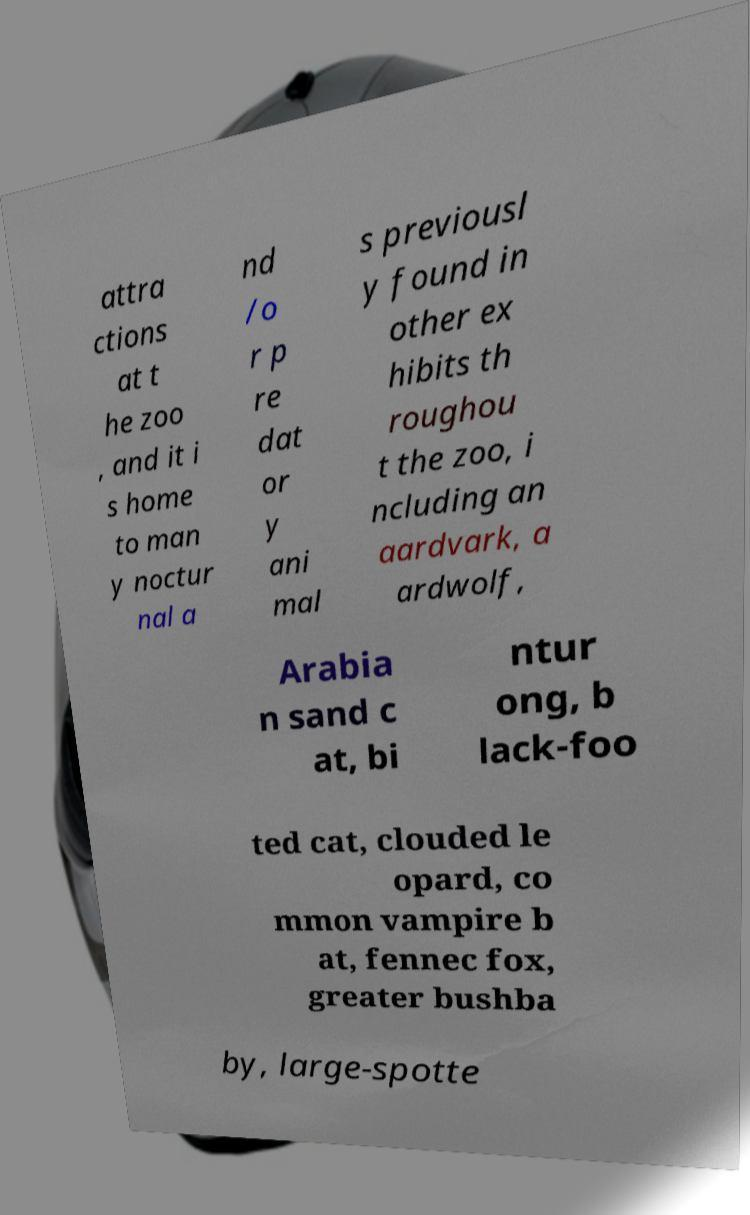Please identify and transcribe the text found in this image. attra ctions at t he zoo , and it i s home to man y noctur nal a nd /o r p re dat or y ani mal s previousl y found in other ex hibits th roughou t the zoo, i ncluding an aardvark, a ardwolf, Arabia n sand c at, bi ntur ong, b lack-foo ted cat, clouded le opard, co mmon vampire b at, fennec fox, greater bushba by, large-spotte 